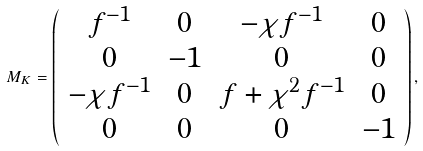<formula> <loc_0><loc_0><loc_500><loc_500>M _ { K } = \left ( \begin{array} { c c c c } f ^ { - 1 } & 0 & - \chi f ^ { - 1 } & 0 \\ 0 & - 1 & 0 & 0 \\ - \chi f ^ { - 1 } & 0 & f + \chi ^ { 2 } f ^ { - 1 } & 0 \\ 0 & 0 & 0 & - 1 \\ \end{array} \right ) ,</formula> 